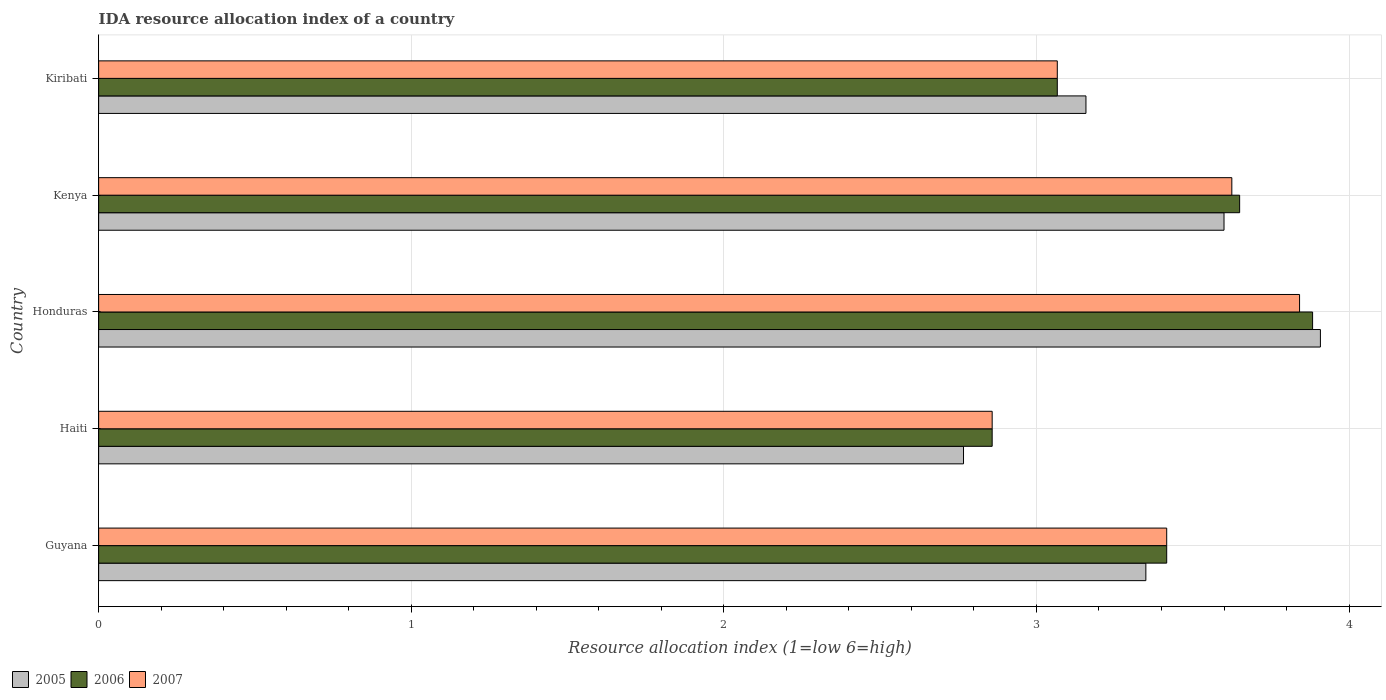How many different coloured bars are there?
Provide a succinct answer. 3. How many groups of bars are there?
Your response must be concise. 5. Are the number of bars per tick equal to the number of legend labels?
Your answer should be compact. Yes. Are the number of bars on each tick of the Y-axis equal?
Provide a succinct answer. Yes. How many bars are there on the 2nd tick from the top?
Your response must be concise. 3. How many bars are there on the 3rd tick from the bottom?
Your response must be concise. 3. What is the label of the 1st group of bars from the top?
Provide a short and direct response. Kiribati. What is the IDA resource allocation index in 2007 in Honduras?
Provide a short and direct response. 3.84. Across all countries, what is the maximum IDA resource allocation index in 2007?
Your answer should be compact. 3.84. Across all countries, what is the minimum IDA resource allocation index in 2006?
Offer a very short reply. 2.86. In which country was the IDA resource allocation index in 2006 maximum?
Make the answer very short. Honduras. In which country was the IDA resource allocation index in 2005 minimum?
Ensure brevity in your answer.  Haiti. What is the total IDA resource allocation index in 2005 in the graph?
Your answer should be very brief. 16.78. What is the difference between the IDA resource allocation index in 2006 in Honduras and that in Kiribati?
Offer a very short reply. 0.82. What is the difference between the IDA resource allocation index in 2005 in Guyana and the IDA resource allocation index in 2006 in Haiti?
Offer a very short reply. 0.49. What is the average IDA resource allocation index in 2005 per country?
Your response must be concise. 3.36. What is the difference between the IDA resource allocation index in 2005 and IDA resource allocation index in 2006 in Honduras?
Make the answer very short. 0.02. In how many countries, is the IDA resource allocation index in 2006 greater than 1.4 ?
Your response must be concise. 5. What is the ratio of the IDA resource allocation index in 2005 in Guyana to that in Kiribati?
Your response must be concise. 1.06. Is the IDA resource allocation index in 2006 in Guyana less than that in Kenya?
Make the answer very short. Yes. What is the difference between the highest and the second highest IDA resource allocation index in 2005?
Give a very brief answer. 0.31. What is the difference between the highest and the lowest IDA resource allocation index in 2007?
Keep it short and to the point. 0.98. What does the 3rd bar from the top in Kiribati represents?
Your answer should be very brief. 2005. What does the 1st bar from the bottom in Kiribati represents?
Your answer should be compact. 2005. How many bars are there?
Keep it short and to the point. 15. What is the difference between two consecutive major ticks on the X-axis?
Make the answer very short. 1. Are the values on the major ticks of X-axis written in scientific E-notation?
Offer a terse response. No. Where does the legend appear in the graph?
Provide a succinct answer. Bottom left. How are the legend labels stacked?
Your answer should be very brief. Horizontal. What is the title of the graph?
Provide a succinct answer. IDA resource allocation index of a country. Does "1966" appear as one of the legend labels in the graph?
Your response must be concise. No. What is the label or title of the X-axis?
Ensure brevity in your answer.  Resource allocation index (1=low 6=high). What is the Resource allocation index (1=low 6=high) of 2005 in Guyana?
Offer a terse response. 3.35. What is the Resource allocation index (1=low 6=high) of 2006 in Guyana?
Ensure brevity in your answer.  3.42. What is the Resource allocation index (1=low 6=high) in 2007 in Guyana?
Offer a terse response. 3.42. What is the Resource allocation index (1=low 6=high) in 2005 in Haiti?
Your response must be concise. 2.77. What is the Resource allocation index (1=low 6=high) in 2006 in Haiti?
Provide a short and direct response. 2.86. What is the Resource allocation index (1=low 6=high) in 2007 in Haiti?
Give a very brief answer. 2.86. What is the Resource allocation index (1=low 6=high) in 2005 in Honduras?
Your response must be concise. 3.91. What is the Resource allocation index (1=low 6=high) in 2006 in Honduras?
Provide a succinct answer. 3.88. What is the Resource allocation index (1=low 6=high) in 2007 in Honduras?
Make the answer very short. 3.84. What is the Resource allocation index (1=low 6=high) of 2005 in Kenya?
Ensure brevity in your answer.  3.6. What is the Resource allocation index (1=low 6=high) in 2006 in Kenya?
Ensure brevity in your answer.  3.65. What is the Resource allocation index (1=low 6=high) of 2007 in Kenya?
Your response must be concise. 3.62. What is the Resource allocation index (1=low 6=high) of 2005 in Kiribati?
Offer a very short reply. 3.16. What is the Resource allocation index (1=low 6=high) of 2006 in Kiribati?
Your response must be concise. 3.07. What is the Resource allocation index (1=low 6=high) in 2007 in Kiribati?
Your answer should be compact. 3.07. Across all countries, what is the maximum Resource allocation index (1=low 6=high) in 2005?
Provide a succinct answer. 3.91. Across all countries, what is the maximum Resource allocation index (1=low 6=high) in 2006?
Your response must be concise. 3.88. Across all countries, what is the maximum Resource allocation index (1=low 6=high) of 2007?
Make the answer very short. 3.84. Across all countries, what is the minimum Resource allocation index (1=low 6=high) in 2005?
Give a very brief answer. 2.77. Across all countries, what is the minimum Resource allocation index (1=low 6=high) of 2006?
Your answer should be very brief. 2.86. Across all countries, what is the minimum Resource allocation index (1=low 6=high) of 2007?
Keep it short and to the point. 2.86. What is the total Resource allocation index (1=low 6=high) in 2005 in the graph?
Make the answer very short. 16.78. What is the total Resource allocation index (1=low 6=high) in 2006 in the graph?
Make the answer very short. 16.88. What is the total Resource allocation index (1=low 6=high) in 2007 in the graph?
Offer a very short reply. 16.81. What is the difference between the Resource allocation index (1=low 6=high) of 2005 in Guyana and that in Haiti?
Offer a very short reply. 0.58. What is the difference between the Resource allocation index (1=low 6=high) of 2006 in Guyana and that in Haiti?
Make the answer very short. 0.56. What is the difference between the Resource allocation index (1=low 6=high) of 2007 in Guyana and that in Haiti?
Ensure brevity in your answer.  0.56. What is the difference between the Resource allocation index (1=low 6=high) in 2005 in Guyana and that in Honduras?
Offer a very short reply. -0.56. What is the difference between the Resource allocation index (1=low 6=high) of 2006 in Guyana and that in Honduras?
Offer a very short reply. -0.47. What is the difference between the Resource allocation index (1=low 6=high) of 2007 in Guyana and that in Honduras?
Give a very brief answer. -0.42. What is the difference between the Resource allocation index (1=low 6=high) in 2005 in Guyana and that in Kenya?
Give a very brief answer. -0.25. What is the difference between the Resource allocation index (1=low 6=high) in 2006 in Guyana and that in Kenya?
Give a very brief answer. -0.23. What is the difference between the Resource allocation index (1=low 6=high) in 2007 in Guyana and that in Kenya?
Keep it short and to the point. -0.21. What is the difference between the Resource allocation index (1=low 6=high) in 2005 in Guyana and that in Kiribati?
Your answer should be very brief. 0.19. What is the difference between the Resource allocation index (1=low 6=high) of 2005 in Haiti and that in Honduras?
Keep it short and to the point. -1.14. What is the difference between the Resource allocation index (1=low 6=high) of 2006 in Haiti and that in Honduras?
Make the answer very short. -1.02. What is the difference between the Resource allocation index (1=low 6=high) of 2007 in Haiti and that in Honduras?
Offer a terse response. -0.98. What is the difference between the Resource allocation index (1=low 6=high) in 2006 in Haiti and that in Kenya?
Your response must be concise. -0.79. What is the difference between the Resource allocation index (1=low 6=high) in 2007 in Haiti and that in Kenya?
Offer a terse response. -0.77. What is the difference between the Resource allocation index (1=low 6=high) in 2005 in Haiti and that in Kiribati?
Provide a succinct answer. -0.39. What is the difference between the Resource allocation index (1=low 6=high) in 2006 in Haiti and that in Kiribati?
Ensure brevity in your answer.  -0.21. What is the difference between the Resource allocation index (1=low 6=high) in 2007 in Haiti and that in Kiribati?
Ensure brevity in your answer.  -0.21. What is the difference between the Resource allocation index (1=low 6=high) of 2005 in Honduras and that in Kenya?
Offer a terse response. 0.31. What is the difference between the Resource allocation index (1=low 6=high) in 2006 in Honduras and that in Kenya?
Offer a very short reply. 0.23. What is the difference between the Resource allocation index (1=low 6=high) of 2007 in Honduras and that in Kenya?
Offer a very short reply. 0.22. What is the difference between the Resource allocation index (1=low 6=high) in 2006 in Honduras and that in Kiribati?
Ensure brevity in your answer.  0.82. What is the difference between the Resource allocation index (1=low 6=high) of 2007 in Honduras and that in Kiribati?
Your answer should be compact. 0.78. What is the difference between the Resource allocation index (1=low 6=high) of 2005 in Kenya and that in Kiribati?
Your answer should be very brief. 0.44. What is the difference between the Resource allocation index (1=low 6=high) of 2006 in Kenya and that in Kiribati?
Offer a terse response. 0.58. What is the difference between the Resource allocation index (1=low 6=high) in 2007 in Kenya and that in Kiribati?
Offer a very short reply. 0.56. What is the difference between the Resource allocation index (1=low 6=high) in 2005 in Guyana and the Resource allocation index (1=low 6=high) in 2006 in Haiti?
Offer a terse response. 0.49. What is the difference between the Resource allocation index (1=low 6=high) in 2005 in Guyana and the Resource allocation index (1=low 6=high) in 2007 in Haiti?
Your answer should be compact. 0.49. What is the difference between the Resource allocation index (1=low 6=high) in 2006 in Guyana and the Resource allocation index (1=low 6=high) in 2007 in Haiti?
Make the answer very short. 0.56. What is the difference between the Resource allocation index (1=low 6=high) of 2005 in Guyana and the Resource allocation index (1=low 6=high) of 2006 in Honduras?
Give a very brief answer. -0.53. What is the difference between the Resource allocation index (1=low 6=high) in 2005 in Guyana and the Resource allocation index (1=low 6=high) in 2007 in Honduras?
Provide a succinct answer. -0.49. What is the difference between the Resource allocation index (1=low 6=high) in 2006 in Guyana and the Resource allocation index (1=low 6=high) in 2007 in Honduras?
Your answer should be very brief. -0.42. What is the difference between the Resource allocation index (1=low 6=high) in 2005 in Guyana and the Resource allocation index (1=low 6=high) in 2006 in Kenya?
Make the answer very short. -0.3. What is the difference between the Resource allocation index (1=low 6=high) of 2005 in Guyana and the Resource allocation index (1=low 6=high) of 2007 in Kenya?
Keep it short and to the point. -0.28. What is the difference between the Resource allocation index (1=low 6=high) of 2006 in Guyana and the Resource allocation index (1=low 6=high) of 2007 in Kenya?
Give a very brief answer. -0.21. What is the difference between the Resource allocation index (1=low 6=high) of 2005 in Guyana and the Resource allocation index (1=low 6=high) of 2006 in Kiribati?
Make the answer very short. 0.28. What is the difference between the Resource allocation index (1=low 6=high) in 2005 in Guyana and the Resource allocation index (1=low 6=high) in 2007 in Kiribati?
Provide a short and direct response. 0.28. What is the difference between the Resource allocation index (1=low 6=high) of 2006 in Guyana and the Resource allocation index (1=low 6=high) of 2007 in Kiribati?
Provide a short and direct response. 0.35. What is the difference between the Resource allocation index (1=low 6=high) in 2005 in Haiti and the Resource allocation index (1=low 6=high) in 2006 in Honduras?
Offer a very short reply. -1.12. What is the difference between the Resource allocation index (1=low 6=high) in 2005 in Haiti and the Resource allocation index (1=low 6=high) in 2007 in Honduras?
Ensure brevity in your answer.  -1.07. What is the difference between the Resource allocation index (1=low 6=high) in 2006 in Haiti and the Resource allocation index (1=low 6=high) in 2007 in Honduras?
Your answer should be very brief. -0.98. What is the difference between the Resource allocation index (1=low 6=high) in 2005 in Haiti and the Resource allocation index (1=low 6=high) in 2006 in Kenya?
Make the answer very short. -0.88. What is the difference between the Resource allocation index (1=low 6=high) in 2005 in Haiti and the Resource allocation index (1=low 6=high) in 2007 in Kenya?
Your answer should be very brief. -0.86. What is the difference between the Resource allocation index (1=low 6=high) in 2006 in Haiti and the Resource allocation index (1=low 6=high) in 2007 in Kenya?
Provide a succinct answer. -0.77. What is the difference between the Resource allocation index (1=low 6=high) in 2005 in Haiti and the Resource allocation index (1=low 6=high) in 2006 in Kiribati?
Give a very brief answer. -0.3. What is the difference between the Resource allocation index (1=low 6=high) in 2006 in Haiti and the Resource allocation index (1=low 6=high) in 2007 in Kiribati?
Ensure brevity in your answer.  -0.21. What is the difference between the Resource allocation index (1=low 6=high) of 2005 in Honduras and the Resource allocation index (1=low 6=high) of 2006 in Kenya?
Offer a very short reply. 0.26. What is the difference between the Resource allocation index (1=low 6=high) of 2005 in Honduras and the Resource allocation index (1=low 6=high) of 2007 in Kenya?
Give a very brief answer. 0.28. What is the difference between the Resource allocation index (1=low 6=high) in 2006 in Honduras and the Resource allocation index (1=low 6=high) in 2007 in Kenya?
Keep it short and to the point. 0.26. What is the difference between the Resource allocation index (1=low 6=high) of 2005 in Honduras and the Resource allocation index (1=low 6=high) of 2006 in Kiribati?
Offer a terse response. 0.84. What is the difference between the Resource allocation index (1=low 6=high) of 2005 in Honduras and the Resource allocation index (1=low 6=high) of 2007 in Kiribati?
Provide a short and direct response. 0.84. What is the difference between the Resource allocation index (1=low 6=high) of 2006 in Honduras and the Resource allocation index (1=low 6=high) of 2007 in Kiribati?
Ensure brevity in your answer.  0.82. What is the difference between the Resource allocation index (1=low 6=high) in 2005 in Kenya and the Resource allocation index (1=low 6=high) in 2006 in Kiribati?
Your answer should be compact. 0.53. What is the difference between the Resource allocation index (1=low 6=high) of 2005 in Kenya and the Resource allocation index (1=low 6=high) of 2007 in Kiribati?
Your answer should be very brief. 0.53. What is the difference between the Resource allocation index (1=low 6=high) in 2006 in Kenya and the Resource allocation index (1=low 6=high) in 2007 in Kiribati?
Offer a very short reply. 0.58. What is the average Resource allocation index (1=low 6=high) of 2005 per country?
Your answer should be compact. 3.36. What is the average Resource allocation index (1=low 6=high) in 2006 per country?
Keep it short and to the point. 3.38. What is the average Resource allocation index (1=low 6=high) in 2007 per country?
Your answer should be compact. 3.36. What is the difference between the Resource allocation index (1=low 6=high) of 2005 and Resource allocation index (1=low 6=high) of 2006 in Guyana?
Offer a terse response. -0.07. What is the difference between the Resource allocation index (1=low 6=high) in 2005 and Resource allocation index (1=low 6=high) in 2007 in Guyana?
Your answer should be compact. -0.07. What is the difference between the Resource allocation index (1=low 6=high) in 2006 and Resource allocation index (1=low 6=high) in 2007 in Guyana?
Offer a terse response. 0. What is the difference between the Resource allocation index (1=low 6=high) in 2005 and Resource allocation index (1=low 6=high) in 2006 in Haiti?
Your answer should be compact. -0.09. What is the difference between the Resource allocation index (1=low 6=high) in 2005 and Resource allocation index (1=low 6=high) in 2007 in Haiti?
Give a very brief answer. -0.09. What is the difference between the Resource allocation index (1=low 6=high) in 2005 and Resource allocation index (1=low 6=high) in 2006 in Honduras?
Offer a very short reply. 0.03. What is the difference between the Resource allocation index (1=low 6=high) in 2005 and Resource allocation index (1=low 6=high) in 2007 in Honduras?
Offer a terse response. 0.07. What is the difference between the Resource allocation index (1=low 6=high) of 2006 and Resource allocation index (1=low 6=high) of 2007 in Honduras?
Make the answer very short. 0.04. What is the difference between the Resource allocation index (1=low 6=high) of 2005 and Resource allocation index (1=low 6=high) of 2006 in Kenya?
Your answer should be very brief. -0.05. What is the difference between the Resource allocation index (1=low 6=high) in 2005 and Resource allocation index (1=low 6=high) in 2007 in Kenya?
Your answer should be very brief. -0.03. What is the difference between the Resource allocation index (1=low 6=high) of 2006 and Resource allocation index (1=low 6=high) of 2007 in Kenya?
Offer a terse response. 0.03. What is the difference between the Resource allocation index (1=low 6=high) in 2005 and Resource allocation index (1=low 6=high) in 2006 in Kiribati?
Make the answer very short. 0.09. What is the difference between the Resource allocation index (1=low 6=high) in 2005 and Resource allocation index (1=low 6=high) in 2007 in Kiribati?
Give a very brief answer. 0.09. What is the difference between the Resource allocation index (1=low 6=high) of 2006 and Resource allocation index (1=low 6=high) of 2007 in Kiribati?
Offer a very short reply. 0. What is the ratio of the Resource allocation index (1=low 6=high) of 2005 in Guyana to that in Haiti?
Make the answer very short. 1.21. What is the ratio of the Resource allocation index (1=low 6=high) of 2006 in Guyana to that in Haiti?
Your response must be concise. 1.2. What is the ratio of the Resource allocation index (1=low 6=high) of 2007 in Guyana to that in Haiti?
Your answer should be compact. 1.2. What is the ratio of the Resource allocation index (1=low 6=high) of 2005 in Guyana to that in Honduras?
Make the answer very short. 0.86. What is the ratio of the Resource allocation index (1=low 6=high) of 2006 in Guyana to that in Honduras?
Your response must be concise. 0.88. What is the ratio of the Resource allocation index (1=low 6=high) of 2007 in Guyana to that in Honduras?
Provide a short and direct response. 0.89. What is the ratio of the Resource allocation index (1=low 6=high) of 2005 in Guyana to that in Kenya?
Your answer should be very brief. 0.93. What is the ratio of the Resource allocation index (1=low 6=high) in 2006 in Guyana to that in Kenya?
Make the answer very short. 0.94. What is the ratio of the Resource allocation index (1=low 6=high) of 2007 in Guyana to that in Kenya?
Ensure brevity in your answer.  0.94. What is the ratio of the Resource allocation index (1=low 6=high) of 2005 in Guyana to that in Kiribati?
Keep it short and to the point. 1.06. What is the ratio of the Resource allocation index (1=low 6=high) in 2006 in Guyana to that in Kiribati?
Give a very brief answer. 1.11. What is the ratio of the Resource allocation index (1=low 6=high) of 2007 in Guyana to that in Kiribati?
Ensure brevity in your answer.  1.11. What is the ratio of the Resource allocation index (1=low 6=high) in 2005 in Haiti to that in Honduras?
Provide a short and direct response. 0.71. What is the ratio of the Resource allocation index (1=low 6=high) in 2006 in Haiti to that in Honduras?
Make the answer very short. 0.74. What is the ratio of the Resource allocation index (1=low 6=high) of 2007 in Haiti to that in Honduras?
Your response must be concise. 0.74. What is the ratio of the Resource allocation index (1=low 6=high) of 2005 in Haiti to that in Kenya?
Your answer should be compact. 0.77. What is the ratio of the Resource allocation index (1=low 6=high) in 2006 in Haiti to that in Kenya?
Keep it short and to the point. 0.78. What is the ratio of the Resource allocation index (1=low 6=high) of 2007 in Haiti to that in Kenya?
Offer a very short reply. 0.79. What is the ratio of the Resource allocation index (1=low 6=high) of 2005 in Haiti to that in Kiribati?
Ensure brevity in your answer.  0.88. What is the ratio of the Resource allocation index (1=low 6=high) in 2006 in Haiti to that in Kiribati?
Your answer should be compact. 0.93. What is the ratio of the Resource allocation index (1=low 6=high) of 2007 in Haiti to that in Kiribati?
Your response must be concise. 0.93. What is the ratio of the Resource allocation index (1=low 6=high) in 2005 in Honduras to that in Kenya?
Your response must be concise. 1.09. What is the ratio of the Resource allocation index (1=low 6=high) of 2006 in Honduras to that in Kenya?
Your answer should be compact. 1.06. What is the ratio of the Resource allocation index (1=low 6=high) of 2007 in Honduras to that in Kenya?
Your response must be concise. 1.06. What is the ratio of the Resource allocation index (1=low 6=high) of 2005 in Honduras to that in Kiribati?
Keep it short and to the point. 1.24. What is the ratio of the Resource allocation index (1=low 6=high) of 2006 in Honduras to that in Kiribati?
Keep it short and to the point. 1.27. What is the ratio of the Resource allocation index (1=low 6=high) in 2007 in Honduras to that in Kiribati?
Make the answer very short. 1.25. What is the ratio of the Resource allocation index (1=low 6=high) of 2005 in Kenya to that in Kiribati?
Your response must be concise. 1.14. What is the ratio of the Resource allocation index (1=low 6=high) in 2006 in Kenya to that in Kiribati?
Offer a terse response. 1.19. What is the ratio of the Resource allocation index (1=low 6=high) in 2007 in Kenya to that in Kiribati?
Provide a succinct answer. 1.18. What is the difference between the highest and the second highest Resource allocation index (1=low 6=high) of 2005?
Ensure brevity in your answer.  0.31. What is the difference between the highest and the second highest Resource allocation index (1=low 6=high) in 2006?
Ensure brevity in your answer.  0.23. What is the difference between the highest and the second highest Resource allocation index (1=low 6=high) in 2007?
Your answer should be compact. 0.22. What is the difference between the highest and the lowest Resource allocation index (1=low 6=high) of 2005?
Keep it short and to the point. 1.14. What is the difference between the highest and the lowest Resource allocation index (1=low 6=high) in 2007?
Ensure brevity in your answer.  0.98. 